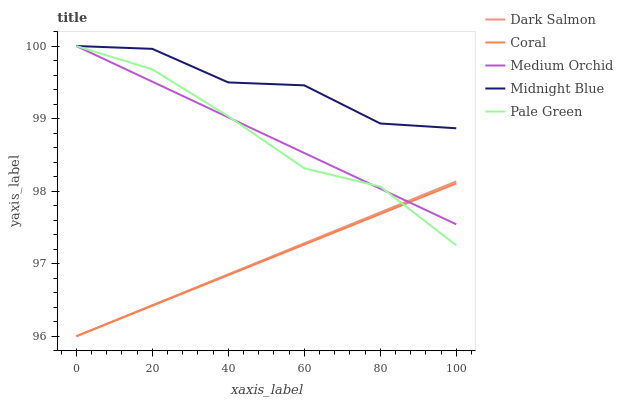Does Coral have the minimum area under the curve?
Answer yes or no. Yes. Does Midnight Blue have the maximum area under the curve?
Answer yes or no. Yes. Does Medium Orchid have the minimum area under the curve?
Answer yes or no. No. Does Medium Orchid have the maximum area under the curve?
Answer yes or no. No. Is Medium Orchid the smoothest?
Answer yes or no. Yes. Is Midnight Blue the roughest?
Answer yes or no. Yes. Is Coral the smoothest?
Answer yes or no. No. Is Coral the roughest?
Answer yes or no. No. Does Coral have the lowest value?
Answer yes or no. Yes. Does Medium Orchid have the lowest value?
Answer yes or no. No. Does Midnight Blue have the highest value?
Answer yes or no. Yes. Does Coral have the highest value?
Answer yes or no. No. Is Coral less than Midnight Blue?
Answer yes or no. Yes. Is Midnight Blue greater than Dark Salmon?
Answer yes or no. Yes. Does Dark Salmon intersect Medium Orchid?
Answer yes or no. Yes. Is Dark Salmon less than Medium Orchid?
Answer yes or no. No. Is Dark Salmon greater than Medium Orchid?
Answer yes or no. No. Does Coral intersect Midnight Blue?
Answer yes or no. No. 